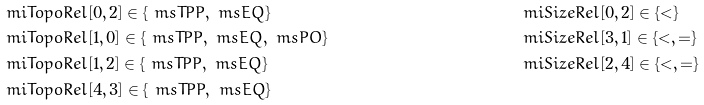<formula> <loc_0><loc_0><loc_500><loc_500>& \ m i { T o p o R e l } [ 0 , 2 ] \in \{ \ m s { T P P } , \ m s { E Q } \} & & \ m i { S i z e R e l } [ 0 , 2 ] \in \{ < \} \\ & \ m i { T o p o R e l } [ 1 , 0 ] \in \{ \ m s { T P P } , \ m s { E Q } , \ m s { P O } \} & & \ m i { S i z e R e l } [ 3 , 1 ] \in \{ < , = \} \\ & \ m i { T o p o R e l } [ 1 , 2 ] \in \{ \ m s { T P P } , \ m s { E Q } \} & & \ m i { S i z e R e l } [ 2 , 4 ] \in \{ < , = \} \\ & \ m i { T o p o R e l } [ 4 , 3 ] \in \{ \ m s { T P P } , \ m s { E Q } \}</formula> 